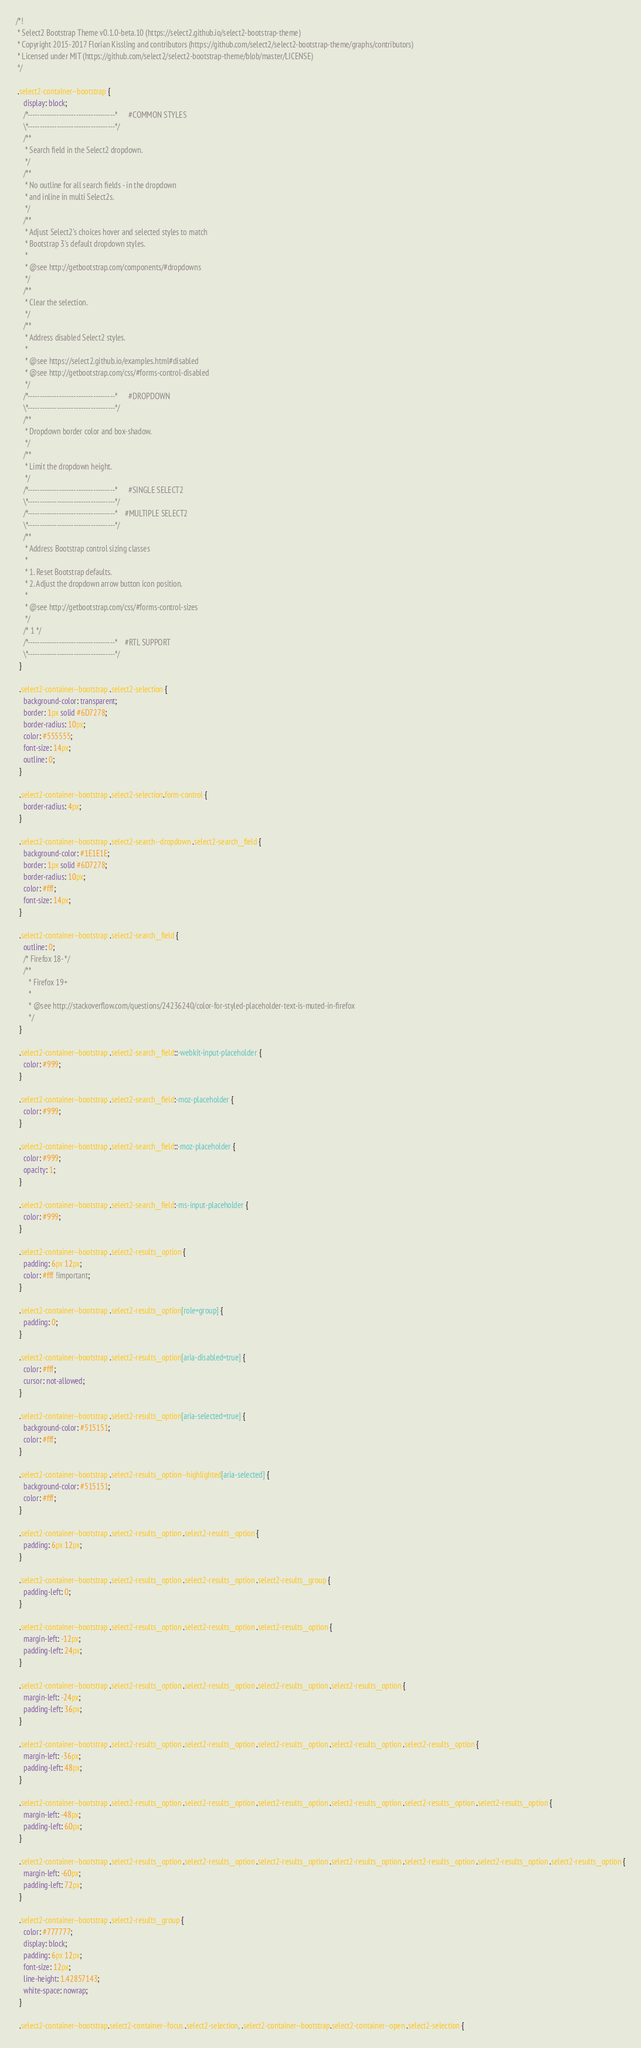Convert code to text. <code><loc_0><loc_0><loc_500><loc_500><_CSS_>/*!
 * Select2 Bootstrap Theme v0.1.0-beta.10 (https://select2.github.io/select2-bootstrap-theme)
 * Copyright 2015-2017 Florian Kissling and contributors (https://github.com/select2/select2-bootstrap-theme/graphs/contributors)
 * Licensed under MIT (https://github.com/select2/select2-bootstrap-theme/blob/master/LICENSE)
 */

 .select2-container--bootstrap {
    display: block;
    /*------------------------------------*      #COMMON STYLES
    \*------------------------------------*/
    /**
     * Search field in the Select2 dropdown.
     */
    /**
     * No outline for all search fields - in the dropdown
     * and inline in multi Select2s.
     */
    /**
     * Adjust Select2's choices hover and selected styles to match
     * Bootstrap 3's default dropdown styles.
     *
     * @see http://getbootstrap.com/components/#dropdowns
     */
    /**
     * Clear the selection.
     */
    /**
     * Address disabled Select2 styles.
     *
     * @see https://select2.github.io/examples.html#disabled
     * @see http://getbootstrap.com/css/#forms-control-disabled
     */
    /*------------------------------------*      #DROPDOWN
    \*------------------------------------*/
    /**
     * Dropdown border color and box-shadow.
     */
    /**
     * Limit the dropdown height.
     */
    /*------------------------------------*      #SINGLE SELECT2
    \*------------------------------------*/
    /*------------------------------------*    #MULTIPLE SELECT2
    \*------------------------------------*/
    /**
     * Address Bootstrap control sizing classes
     *
     * 1. Reset Bootstrap defaults.
     * 2. Adjust the dropdown arrow button icon position.
     *
     * @see http://getbootstrap.com/css/#forms-control-sizes
     */
    /* 1 */
    /*------------------------------------*    #RTL SUPPORT
    \*------------------------------------*/
  }
  
  .select2-container--bootstrap .select2-selection {
    background-color: transparent;
    border: 1px solid #6D7278;
    border-radius: 10px;
    color: #555555;
    font-size: 14px;
    outline: 0;
  }
  
  .select2-container--bootstrap .select2-selection.form-control {
    border-radius: 4px;
  }
  
  .select2-container--bootstrap .select2-search--dropdown .select2-search__field {
    background-color: #1E1E1E;
    border: 1px solid #6D7278;
    border-radius: 10px;
    color: #fff;
    font-size: 14px;
  }
  
  .select2-container--bootstrap .select2-search__field {
    outline: 0;
    /* Firefox 18- */
    /**
       * Firefox 19+
       *
       * @see http://stackoverflow.com/questions/24236240/color-for-styled-placeholder-text-is-muted-in-firefox
       */
  }
  
  .select2-container--bootstrap .select2-search__field::-webkit-input-placeholder {
    color: #999;
  }
  
  .select2-container--bootstrap .select2-search__field:-moz-placeholder {
    color: #999;
  }
  
  .select2-container--bootstrap .select2-search__field::-moz-placeholder {
    color: #999;
    opacity: 1;
  }
  
  .select2-container--bootstrap .select2-search__field:-ms-input-placeholder {
    color: #999;
  }
  
  .select2-container--bootstrap .select2-results__option {
    padding: 6px 12px;
    color: #fff !important;
  }
  
  .select2-container--bootstrap .select2-results__option[role=group] {
    padding: 0;
  }
  
  .select2-container--bootstrap .select2-results__option[aria-disabled=true] {
    color: #fff;
    cursor: not-allowed;
  }
  
  .select2-container--bootstrap .select2-results__option[aria-selected=true] {
    background-color: #515151;
    color: #fff;
  }
  
  .select2-container--bootstrap .select2-results__option--highlighted[aria-selected] {
    background-color: #515151;
    color: #fff;
  }
  
  .select2-container--bootstrap .select2-results__option .select2-results__option {
    padding: 6px 12px;
  }
  
  .select2-container--bootstrap .select2-results__option .select2-results__option .select2-results__group {
    padding-left: 0;
  }
  
  .select2-container--bootstrap .select2-results__option .select2-results__option .select2-results__option {
    margin-left: -12px;
    padding-left: 24px;
  }
  
  .select2-container--bootstrap .select2-results__option .select2-results__option .select2-results__option .select2-results__option {
    margin-left: -24px;
    padding-left: 36px;
  }
  
  .select2-container--bootstrap .select2-results__option .select2-results__option .select2-results__option .select2-results__option .select2-results__option {
    margin-left: -36px;
    padding-left: 48px;
  }
  
  .select2-container--bootstrap .select2-results__option .select2-results__option .select2-results__option .select2-results__option .select2-results__option .select2-results__option {
    margin-left: -48px;
    padding-left: 60px;
  }
  
  .select2-container--bootstrap .select2-results__option .select2-results__option .select2-results__option .select2-results__option .select2-results__option .select2-results__option .select2-results__option {
    margin-left: -60px;
    padding-left: 72px;
  }
  
  .select2-container--bootstrap .select2-results__group {
    color: #777777;
    display: block;
    padding: 6px 12px;
    font-size: 12px;
    line-height: 1.42857143;
    white-space: nowrap;
  }
  
  .select2-container--bootstrap.select2-container--focus .select2-selection, .select2-container--bootstrap.select2-container--open .select2-selection {</code> 